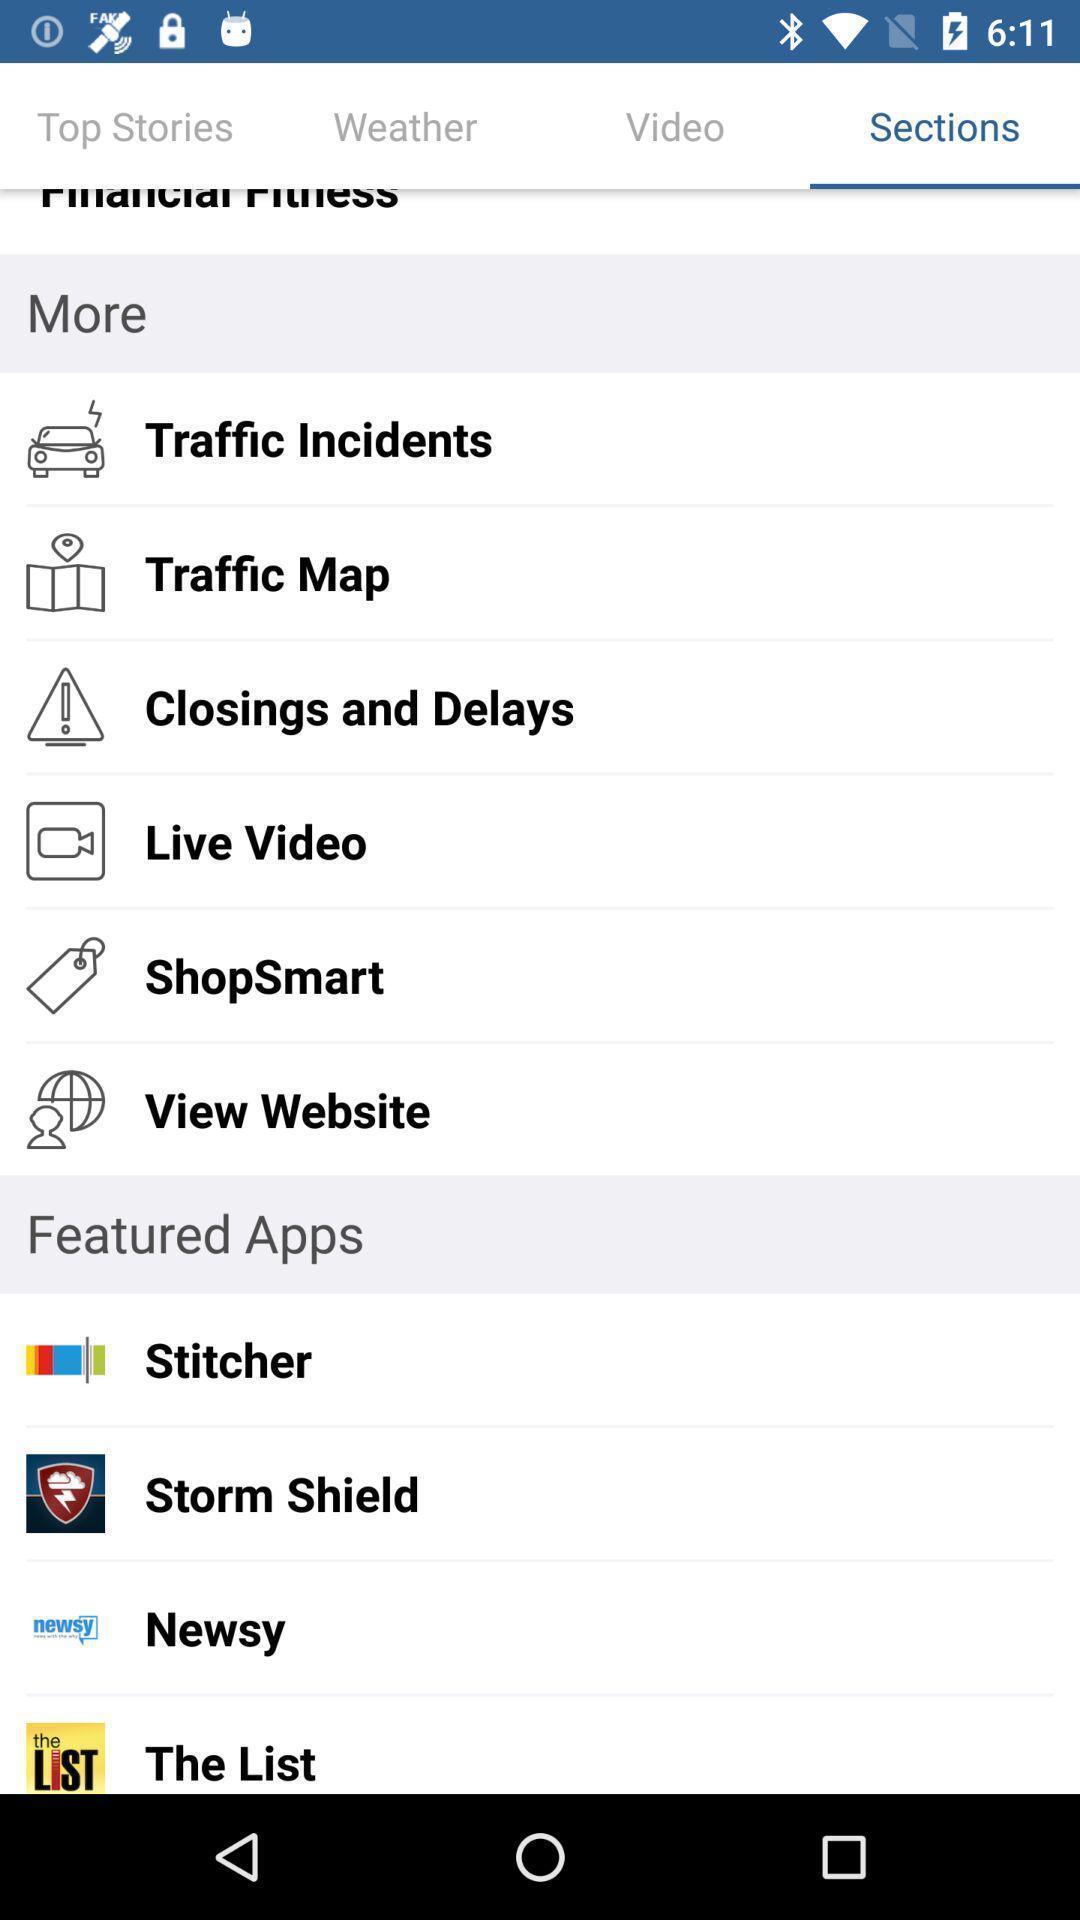Summarize the main components in this picture. Screen showing sections page. 